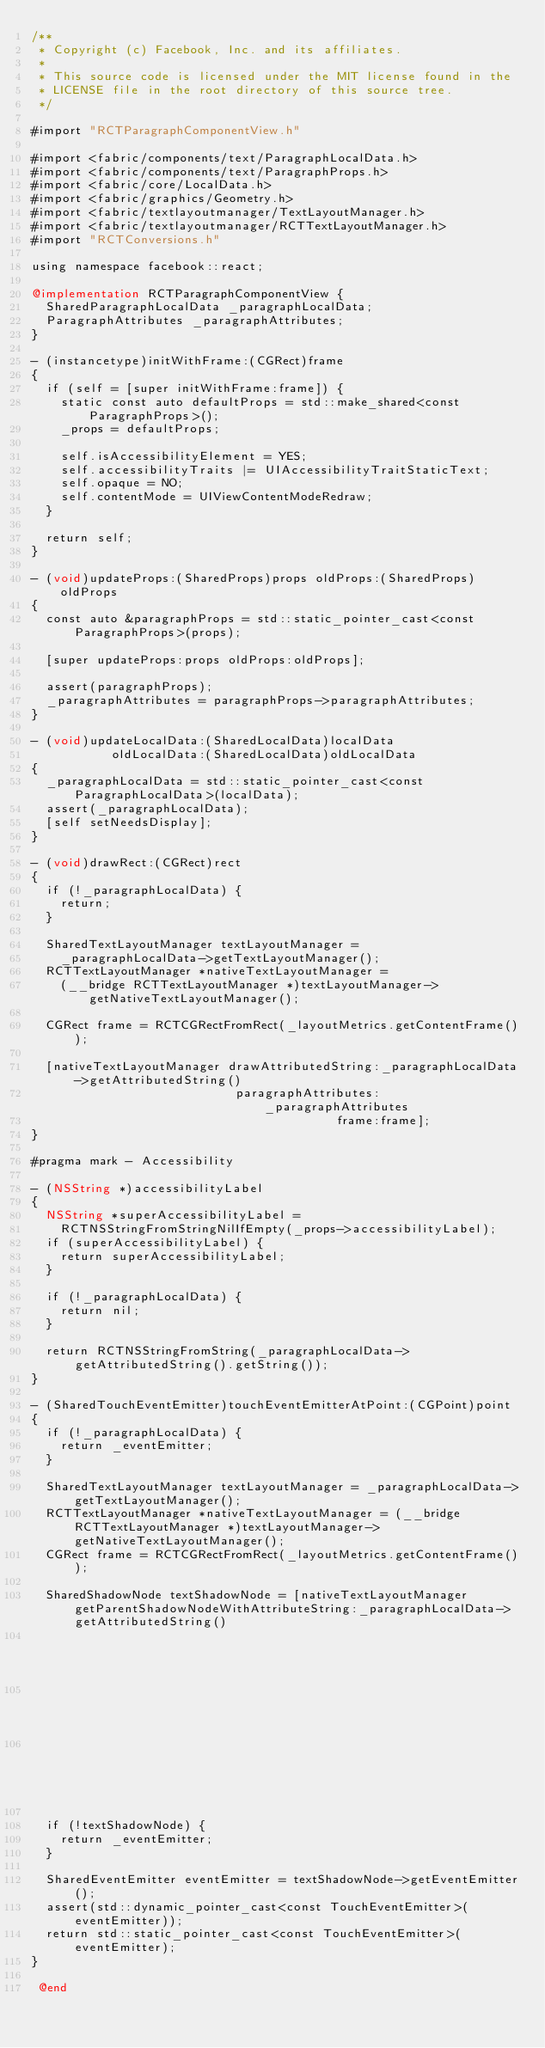Convert code to text. <code><loc_0><loc_0><loc_500><loc_500><_ObjectiveC_>/**
 * Copyright (c) Facebook, Inc. and its affiliates.
 *
 * This source code is licensed under the MIT license found in the
 * LICENSE file in the root directory of this source tree.
 */

#import "RCTParagraphComponentView.h"

#import <fabric/components/text/ParagraphLocalData.h>
#import <fabric/components/text/ParagraphProps.h>
#import <fabric/core/LocalData.h>
#import <fabric/graphics/Geometry.h>
#import <fabric/textlayoutmanager/TextLayoutManager.h>
#import <fabric/textlayoutmanager/RCTTextLayoutManager.h>
#import "RCTConversions.h"

using namespace facebook::react;

@implementation RCTParagraphComponentView {
  SharedParagraphLocalData _paragraphLocalData;
  ParagraphAttributes _paragraphAttributes;
}

- (instancetype)initWithFrame:(CGRect)frame
{
  if (self = [super initWithFrame:frame]) {
    static const auto defaultProps = std::make_shared<const ParagraphProps>();
    _props = defaultProps;

    self.isAccessibilityElement = YES;
    self.accessibilityTraits |= UIAccessibilityTraitStaticText;
    self.opaque = NO;
    self.contentMode = UIViewContentModeRedraw;
  }

  return self;
}

- (void)updateProps:(SharedProps)props oldProps:(SharedProps)oldProps
{
  const auto &paragraphProps = std::static_pointer_cast<const ParagraphProps>(props);

  [super updateProps:props oldProps:oldProps];

  assert(paragraphProps);
  _paragraphAttributes = paragraphProps->paragraphAttributes;
}

- (void)updateLocalData:(SharedLocalData)localData
           oldLocalData:(SharedLocalData)oldLocalData
{
  _paragraphLocalData = std::static_pointer_cast<const ParagraphLocalData>(localData);
  assert(_paragraphLocalData);
  [self setNeedsDisplay];
}

- (void)drawRect:(CGRect)rect
{
  if (!_paragraphLocalData) {
    return;
  }

  SharedTextLayoutManager textLayoutManager =
    _paragraphLocalData->getTextLayoutManager();
  RCTTextLayoutManager *nativeTextLayoutManager =
    (__bridge RCTTextLayoutManager *)textLayoutManager->getNativeTextLayoutManager();

  CGRect frame = RCTCGRectFromRect(_layoutMetrics.getContentFrame());

  [nativeTextLayoutManager drawAttributedString:_paragraphLocalData->getAttributedString()
                            paragraphAttributes:_paragraphAttributes
                                          frame:frame];
}

#pragma mark - Accessibility

- (NSString *)accessibilityLabel
{
  NSString *superAccessibilityLabel =
    RCTNSStringFromStringNilIfEmpty(_props->accessibilityLabel);
  if (superAccessibilityLabel) {
    return superAccessibilityLabel;
  }

  if (!_paragraphLocalData) {
    return nil;
  }

  return RCTNSStringFromString(_paragraphLocalData->getAttributedString().getString());
}

- (SharedTouchEventEmitter)touchEventEmitterAtPoint:(CGPoint)point
{
  if (!_paragraphLocalData) {
    return _eventEmitter;
  }

  SharedTextLayoutManager textLayoutManager = _paragraphLocalData->getTextLayoutManager();
  RCTTextLayoutManager *nativeTextLayoutManager = (__bridge RCTTextLayoutManager *)textLayoutManager->getNativeTextLayoutManager();
  CGRect frame = RCTCGRectFromRect(_layoutMetrics.getContentFrame());

  SharedShadowNode textShadowNode = [nativeTextLayoutManager getParentShadowNodeWithAttributeString:_paragraphLocalData->getAttributedString()
                                                                                paragraphAttributes:_paragraphAttributes
                                                                                              frame:frame
                                                                                            atPoint:point];

  if (!textShadowNode) {
    return _eventEmitter;
  }

  SharedEventEmitter eventEmitter = textShadowNode->getEventEmitter();
  assert(std::dynamic_pointer_cast<const TouchEventEmitter>(eventEmitter));
  return std::static_pointer_cast<const TouchEventEmitter>(eventEmitter);
}

 @end
</code> 